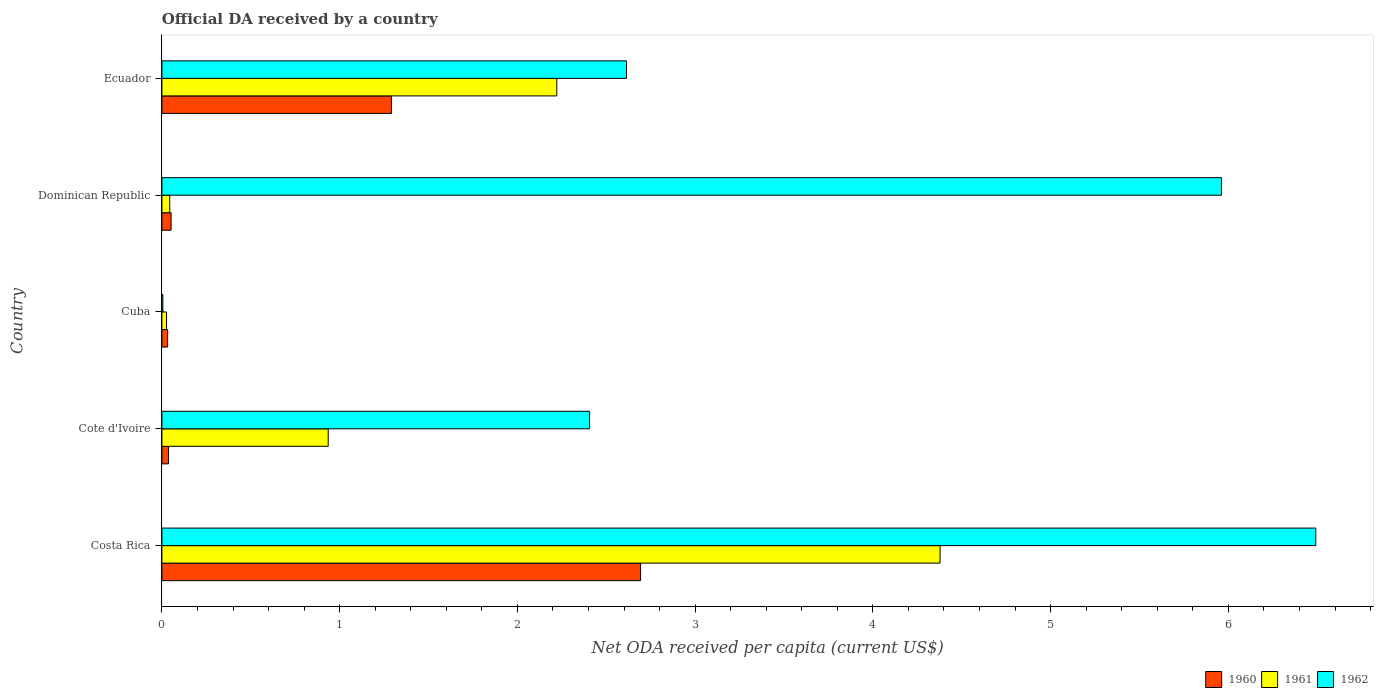How many different coloured bars are there?
Your answer should be compact. 3. Are the number of bars per tick equal to the number of legend labels?
Your response must be concise. Yes. Are the number of bars on each tick of the Y-axis equal?
Your answer should be very brief. Yes. What is the label of the 1st group of bars from the top?
Keep it short and to the point. Ecuador. What is the ODA received in in 1962 in Costa Rica?
Keep it short and to the point. 6.49. Across all countries, what is the maximum ODA received in in 1961?
Give a very brief answer. 4.38. Across all countries, what is the minimum ODA received in in 1960?
Your answer should be compact. 0.03. In which country was the ODA received in in 1961 minimum?
Your answer should be compact. Cuba. What is the total ODA received in in 1961 in the graph?
Keep it short and to the point. 7.61. What is the difference between the ODA received in in 1960 in Costa Rica and that in Cuba?
Your answer should be very brief. 2.66. What is the difference between the ODA received in in 1962 in Cuba and the ODA received in in 1961 in Ecuador?
Provide a succinct answer. -2.22. What is the average ODA received in in 1961 per country?
Offer a very short reply. 1.52. What is the difference between the ODA received in in 1961 and ODA received in in 1962 in Costa Rica?
Give a very brief answer. -2.11. What is the ratio of the ODA received in in 1961 in Cote d'Ivoire to that in Ecuador?
Your answer should be very brief. 0.42. Is the ODA received in in 1961 in Costa Rica less than that in Dominican Republic?
Keep it short and to the point. No. What is the difference between the highest and the second highest ODA received in in 1960?
Provide a succinct answer. 1.4. What is the difference between the highest and the lowest ODA received in in 1961?
Provide a short and direct response. 4.35. In how many countries, is the ODA received in in 1962 greater than the average ODA received in in 1962 taken over all countries?
Keep it short and to the point. 2. Is the sum of the ODA received in in 1960 in Dominican Republic and Ecuador greater than the maximum ODA received in in 1962 across all countries?
Give a very brief answer. No. What does the 2nd bar from the bottom in Cuba represents?
Your answer should be compact. 1961. Is it the case that in every country, the sum of the ODA received in in 1960 and ODA received in in 1961 is greater than the ODA received in in 1962?
Keep it short and to the point. No. Are all the bars in the graph horizontal?
Offer a terse response. Yes. Are the values on the major ticks of X-axis written in scientific E-notation?
Keep it short and to the point. No. Does the graph contain any zero values?
Give a very brief answer. No. Where does the legend appear in the graph?
Offer a very short reply. Bottom right. How many legend labels are there?
Provide a short and direct response. 3. What is the title of the graph?
Your response must be concise. Official DA received by a country. Does "1984" appear as one of the legend labels in the graph?
Ensure brevity in your answer.  No. What is the label or title of the X-axis?
Your response must be concise. Net ODA received per capita (current US$). What is the Net ODA received per capita (current US$) in 1960 in Costa Rica?
Offer a terse response. 2.69. What is the Net ODA received per capita (current US$) in 1961 in Costa Rica?
Make the answer very short. 4.38. What is the Net ODA received per capita (current US$) in 1962 in Costa Rica?
Provide a short and direct response. 6.49. What is the Net ODA received per capita (current US$) in 1960 in Cote d'Ivoire?
Give a very brief answer. 0.04. What is the Net ODA received per capita (current US$) of 1961 in Cote d'Ivoire?
Give a very brief answer. 0.94. What is the Net ODA received per capita (current US$) of 1962 in Cote d'Ivoire?
Your answer should be very brief. 2.41. What is the Net ODA received per capita (current US$) of 1960 in Cuba?
Give a very brief answer. 0.03. What is the Net ODA received per capita (current US$) in 1961 in Cuba?
Offer a terse response. 0.03. What is the Net ODA received per capita (current US$) of 1962 in Cuba?
Provide a short and direct response. 0.01. What is the Net ODA received per capita (current US$) in 1960 in Dominican Republic?
Offer a very short reply. 0.05. What is the Net ODA received per capita (current US$) in 1961 in Dominican Republic?
Ensure brevity in your answer.  0.04. What is the Net ODA received per capita (current US$) in 1962 in Dominican Republic?
Your answer should be very brief. 5.96. What is the Net ODA received per capita (current US$) in 1960 in Ecuador?
Offer a very short reply. 1.29. What is the Net ODA received per capita (current US$) of 1961 in Ecuador?
Your answer should be very brief. 2.22. What is the Net ODA received per capita (current US$) in 1962 in Ecuador?
Offer a very short reply. 2.61. Across all countries, what is the maximum Net ODA received per capita (current US$) in 1960?
Make the answer very short. 2.69. Across all countries, what is the maximum Net ODA received per capita (current US$) in 1961?
Provide a short and direct response. 4.38. Across all countries, what is the maximum Net ODA received per capita (current US$) in 1962?
Keep it short and to the point. 6.49. Across all countries, what is the minimum Net ODA received per capita (current US$) of 1960?
Provide a succinct answer. 0.03. Across all countries, what is the minimum Net ODA received per capita (current US$) in 1961?
Your answer should be very brief. 0.03. Across all countries, what is the minimum Net ODA received per capita (current US$) of 1962?
Your answer should be very brief. 0.01. What is the total Net ODA received per capita (current US$) of 1960 in the graph?
Provide a succinct answer. 4.11. What is the total Net ODA received per capita (current US$) of 1961 in the graph?
Keep it short and to the point. 7.61. What is the total Net ODA received per capita (current US$) in 1962 in the graph?
Provide a succinct answer. 17.48. What is the difference between the Net ODA received per capita (current US$) in 1960 in Costa Rica and that in Cote d'Ivoire?
Offer a very short reply. 2.66. What is the difference between the Net ODA received per capita (current US$) of 1961 in Costa Rica and that in Cote d'Ivoire?
Provide a short and direct response. 3.44. What is the difference between the Net ODA received per capita (current US$) of 1962 in Costa Rica and that in Cote d'Ivoire?
Your response must be concise. 4.09. What is the difference between the Net ODA received per capita (current US$) of 1960 in Costa Rica and that in Cuba?
Ensure brevity in your answer.  2.66. What is the difference between the Net ODA received per capita (current US$) of 1961 in Costa Rica and that in Cuba?
Offer a very short reply. 4.35. What is the difference between the Net ODA received per capita (current US$) in 1962 in Costa Rica and that in Cuba?
Your response must be concise. 6.49. What is the difference between the Net ODA received per capita (current US$) of 1960 in Costa Rica and that in Dominican Republic?
Offer a very short reply. 2.64. What is the difference between the Net ODA received per capita (current US$) of 1961 in Costa Rica and that in Dominican Republic?
Your response must be concise. 4.33. What is the difference between the Net ODA received per capita (current US$) in 1962 in Costa Rica and that in Dominican Republic?
Offer a terse response. 0.53. What is the difference between the Net ODA received per capita (current US$) in 1960 in Costa Rica and that in Ecuador?
Give a very brief answer. 1.4. What is the difference between the Net ODA received per capita (current US$) of 1961 in Costa Rica and that in Ecuador?
Offer a terse response. 2.16. What is the difference between the Net ODA received per capita (current US$) of 1962 in Costa Rica and that in Ecuador?
Keep it short and to the point. 3.88. What is the difference between the Net ODA received per capita (current US$) in 1960 in Cote d'Ivoire and that in Cuba?
Your answer should be very brief. 0.01. What is the difference between the Net ODA received per capita (current US$) in 1961 in Cote d'Ivoire and that in Cuba?
Keep it short and to the point. 0.91. What is the difference between the Net ODA received per capita (current US$) in 1962 in Cote d'Ivoire and that in Cuba?
Provide a short and direct response. 2.4. What is the difference between the Net ODA received per capita (current US$) of 1960 in Cote d'Ivoire and that in Dominican Republic?
Your answer should be very brief. -0.01. What is the difference between the Net ODA received per capita (current US$) in 1961 in Cote d'Ivoire and that in Dominican Republic?
Give a very brief answer. 0.89. What is the difference between the Net ODA received per capita (current US$) of 1962 in Cote d'Ivoire and that in Dominican Republic?
Make the answer very short. -3.55. What is the difference between the Net ODA received per capita (current US$) of 1960 in Cote d'Ivoire and that in Ecuador?
Your response must be concise. -1.25. What is the difference between the Net ODA received per capita (current US$) of 1961 in Cote d'Ivoire and that in Ecuador?
Give a very brief answer. -1.29. What is the difference between the Net ODA received per capita (current US$) in 1962 in Cote d'Ivoire and that in Ecuador?
Keep it short and to the point. -0.21. What is the difference between the Net ODA received per capita (current US$) in 1960 in Cuba and that in Dominican Republic?
Provide a succinct answer. -0.02. What is the difference between the Net ODA received per capita (current US$) of 1961 in Cuba and that in Dominican Republic?
Your answer should be very brief. -0.02. What is the difference between the Net ODA received per capita (current US$) in 1962 in Cuba and that in Dominican Republic?
Provide a succinct answer. -5.96. What is the difference between the Net ODA received per capita (current US$) in 1960 in Cuba and that in Ecuador?
Offer a terse response. -1.26. What is the difference between the Net ODA received per capita (current US$) of 1961 in Cuba and that in Ecuador?
Give a very brief answer. -2.2. What is the difference between the Net ODA received per capita (current US$) in 1962 in Cuba and that in Ecuador?
Ensure brevity in your answer.  -2.61. What is the difference between the Net ODA received per capita (current US$) of 1960 in Dominican Republic and that in Ecuador?
Make the answer very short. -1.24. What is the difference between the Net ODA received per capita (current US$) in 1961 in Dominican Republic and that in Ecuador?
Offer a terse response. -2.18. What is the difference between the Net ODA received per capita (current US$) in 1962 in Dominican Republic and that in Ecuador?
Provide a short and direct response. 3.35. What is the difference between the Net ODA received per capita (current US$) in 1960 in Costa Rica and the Net ODA received per capita (current US$) in 1961 in Cote d'Ivoire?
Provide a short and direct response. 1.76. What is the difference between the Net ODA received per capita (current US$) of 1960 in Costa Rica and the Net ODA received per capita (current US$) of 1962 in Cote d'Ivoire?
Give a very brief answer. 0.29. What is the difference between the Net ODA received per capita (current US$) of 1961 in Costa Rica and the Net ODA received per capita (current US$) of 1962 in Cote d'Ivoire?
Offer a very short reply. 1.97. What is the difference between the Net ODA received per capita (current US$) of 1960 in Costa Rica and the Net ODA received per capita (current US$) of 1961 in Cuba?
Your answer should be compact. 2.67. What is the difference between the Net ODA received per capita (current US$) of 1960 in Costa Rica and the Net ODA received per capita (current US$) of 1962 in Cuba?
Offer a terse response. 2.69. What is the difference between the Net ODA received per capita (current US$) of 1961 in Costa Rica and the Net ODA received per capita (current US$) of 1962 in Cuba?
Your answer should be compact. 4.37. What is the difference between the Net ODA received per capita (current US$) in 1960 in Costa Rica and the Net ODA received per capita (current US$) in 1961 in Dominican Republic?
Make the answer very short. 2.65. What is the difference between the Net ODA received per capita (current US$) in 1960 in Costa Rica and the Net ODA received per capita (current US$) in 1962 in Dominican Republic?
Your answer should be very brief. -3.27. What is the difference between the Net ODA received per capita (current US$) of 1961 in Costa Rica and the Net ODA received per capita (current US$) of 1962 in Dominican Republic?
Keep it short and to the point. -1.58. What is the difference between the Net ODA received per capita (current US$) in 1960 in Costa Rica and the Net ODA received per capita (current US$) in 1961 in Ecuador?
Ensure brevity in your answer.  0.47. What is the difference between the Net ODA received per capita (current US$) of 1960 in Costa Rica and the Net ODA received per capita (current US$) of 1962 in Ecuador?
Provide a short and direct response. 0.08. What is the difference between the Net ODA received per capita (current US$) of 1961 in Costa Rica and the Net ODA received per capita (current US$) of 1962 in Ecuador?
Keep it short and to the point. 1.76. What is the difference between the Net ODA received per capita (current US$) in 1960 in Cote d'Ivoire and the Net ODA received per capita (current US$) in 1961 in Cuba?
Provide a short and direct response. 0.01. What is the difference between the Net ODA received per capita (current US$) of 1960 in Cote d'Ivoire and the Net ODA received per capita (current US$) of 1962 in Cuba?
Your answer should be very brief. 0.03. What is the difference between the Net ODA received per capita (current US$) in 1961 in Cote d'Ivoire and the Net ODA received per capita (current US$) in 1962 in Cuba?
Your answer should be very brief. 0.93. What is the difference between the Net ODA received per capita (current US$) of 1960 in Cote d'Ivoire and the Net ODA received per capita (current US$) of 1961 in Dominican Republic?
Your answer should be very brief. -0.01. What is the difference between the Net ODA received per capita (current US$) in 1960 in Cote d'Ivoire and the Net ODA received per capita (current US$) in 1962 in Dominican Republic?
Make the answer very short. -5.92. What is the difference between the Net ODA received per capita (current US$) of 1961 in Cote d'Ivoire and the Net ODA received per capita (current US$) of 1962 in Dominican Republic?
Give a very brief answer. -5.03. What is the difference between the Net ODA received per capita (current US$) of 1960 in Cote d'Ivoire and the Net ODA received per capita (current US$) of 1961 in Ecuador?
Give a very brief answer. -2.18. What is the difference between the Net ODA received per capita (current US$) in 1960 in Cote d'Ivoire and the Net ODA received per capita (current US$) in 1962 in Ecuador?
Your response must be concise. -2.58. What is the difference between the Net ODA received per capita (current US$) of 1961 in Cote d'Ivoire and the Net ODA received per capita (current US$) of 1962 in Ecuador?
Provide a succinct answer. -1.68. What is the difference between the Net ODA received per capita (current US$) of 1960 in Cuba and the Net ODA received per capita (current US$) of 1961 in Dominican Republic?
Your answer should be very brief. -0.01. What is the difference between the Net ODA received per capita (current US$) in 1960 in Cuba and the Net ODA received per capita (current US$) in 1962 in Dominican Republic?
Give a very brief answer. -5.93. What is the difference between the Net ODA received per capita (current US$) in 1961 in Cuba and the Net ODA received per capita (current US$) in 1962 in Dominican Republic?
Provide a short and direct response. -5.93. What is the difference between the Net ODA received per capita (current US$) in 1960 in Cuba and the Net ODA received per capita (current US$) in 1961 in Ecuador?
Keep it short and to the point. -2.19. What is the difference between the Net ODA received per capita (current US$) in 1960 in Cuba and the Net ODA received per capita (current US$) in 1962 in Ecuador?
Make the answer very short. -2.58. What is the difference between the Net ODA received per capita (current US$) of 1961 in Cuba and the Net ODA received per capita (current US$) of 1962 in Ecuador?
Your answer should be very brief. -2.59. What is the difference between the Net ODA received per capita (current US$) in 1960 in Dominican Republic and the Net ODA received per capita (current US$) in 1961 in Ecuador?
Provide a succinct answer. -2.17. What is the difference between the Net ODA received per capita (current US$) of 1960 in Dominican Republic and the Net ODA received per capita (current US$) of 1962 in Ecuador?
Offer a terse response. -2.56. What is the difference between the Net ODA received per capita (current US$) of 1961 in Dominican Republic and the Net ODA received per capita (current US$) of 1962 in Ecuador?
Your answer should be very brief. -2.57. What is the average Net ODA received per capita (current US$) in 1960 per country?
Offer a terse response. 0.82. What is the average Net ODA received per capita (current US$) of 1961 per country?
Give a very brief answer. 1.52. What is the average Net ODA received per capita (current US$) in 1962 per country?
Make the answer very short. 3.5. What is the difference between the Net ODA received per capita (current US$) in 1960 and Net ODA received per capita (current US$) in 1961 in Costa Rica?
Keep it short and to the point. -1.68. What is the difference between the Net ODA received per capita (current US$) in 1960 and Net ODA received per capita (current US$) in 1962 in Costa Rica?
Keep it short and to the point. -3.8. What is the difference between the Net ODA received per capita (current US$) of 1961 and Net ODA received per capita (current US$) of 1962 in Costa Rica?
Offer a terse response. -2.11. What is the difference between the Net ODA received per capita (current US$) of 1960 and Net ODA received per capita (current US$) of 1961 in Cote d'Ivoire?
Offer a very short reply. -0.9. What is the difference between the Net ODA received per capita (current US$) of 1960 and Net ODA received per capita (current US$) of 1962 in Cote d'Ivoire?
Your answer should be very brief. -2.37. What is the difference between the Net ODA received per capita (current US$) of 1961 and Net ODA received per capita (current US$) of 1962 in Cote d'Ivoire?
Provide a short and direct response. -1.47. What is the difference between the Net ODA received per capita (current US$) of 1960 and Net ODA received per capita (current US$) of 1961 in Cuba?
Offer a terse response. 0.01. What is the difference between the Net ODA received per capita (current US$) in 1960 and Net ODA received per capita (current US$) in 1962 in Cuba?
Make the answer very short. 0.03. What is the difference between the Net ODA received per capita (current US$) in 1961 and Net ODA received per capita (current US$) in 1962 in Cuba?
Your answer should be compact. 0.02. What is the difference between the Net ODA received per capita (current US$) of 1960 and Net ODA received per capita (current US$) of 1961 in Dominican Republic?
Provide a succinct answer. 0.01. What is the difference between the Net ODA received per capita (current US$) of 1960 and Net ODA received per capita (current US$) of 1962 in Dominican Republic?
Your answer should be compact. -5.91. What is the difference between the Net ODA received per capita (current US$) in 1961 and Net ODA received per capita (current US$) in 1962 in Dominican Republic?
Offer a very short reply. -5.92. What is the difference between the Net ODA received per capita (current US$) of 1960 and Net ODA received per capita (current US$) of 1961 in Ecuador?
Offer a terse response. -0.93. What is the difference between the Net ODA received per capita (current US$) in 1960 and Net ODA received per capita (current US$) in 1962 in Ecuador?
Provide a short and direct response. -1.32. What is the difference between the Net ODA received per capita (current US$) of 1961 and Net ODA received per capita (current US$) of 1962 in Ecuador?
Your answer should be very brief. -0.39. What is the ratio of the Net ODA received per capita (current US$) of 1960 in Costa Rica to that in Cote d'Ivoire?
Your response must be concise. 71.98. What is the ratio of the Net ODA received per capita (current US$) of 1961 in Costa Rica to that in Cote d'Ivoire?
Your answer should be compact. 4.68. What is the ratio of the Net ODA received per capita (current US$) in 1962 in Costa Rica to that in Cote d'Ivoire?
Offer a very short reply. 2.7. What is the ratio of the Net ODA received per capita (current US$) of 1960 in Costa Rica to that in Cuba?
Offer a terse response. 83.62. What is the ratio of the Net ODA received per capita (current US$) in 1961 in Costa Rica to that in Cuba?
Keep it short and to the point. 167.97. What is the ratio of the Net ODA received per capita (current US$) in 1962 in Costa Rica to that in Cuba?
Provide a short and direct response. 1209.16. What is the ratio of the Net ODA received per capita (current US$) of 1960 in Costa Rica to that in Dominican Republic?
Make the answer very short. 52.18. What is the ratio of the Net ODA received per capita (current US$) of 1961 in Costa Rica to that in Dominican Republic?
Make the answer very short. 99.42. What is the ratio of the Net ODA received per capita (current US$) of 1962 in Costa Rica to that in Dominican Republic?
Your response must be concise. 1.09. What is the ratio of the Net ODA received per capita (current US$) in 1960 in Costa Rica to that in Ecuador?
Your answer should be compact. 2.09. What is the ratio of the Net ODA received per capita (current US$) in 1961 in Costa Rica to that in Ecuador?
Provide a succinct answer. 1.97. What is the ratio of the Net ODA received per capita (current US$) of 1962 in Costa Rica to that in Ecuador?
Give a very brief answer. 2.48. What is the ratio of the Net ODA received per capita (current US$) of 1960 in Cote d'Ivoire to that in Cuba?
Keep it short and to the point. 1.16. What is the ratio of the Net ODA received per capita (current US$) in 1961 in Cote d'Ivoire to that in Cuba?
Your answer should be very brief. 35.9. What is the ratio of the Net ODA received per capita (current US$) of 1962 in Cote d'Ivoire to that in Cuba?
Give a very brief answer. 448.16. What is the ratio of the Net ODA received per capita (current US$) in 1960 in Cote d'Ivoire to that in Dominican Republic?
Your answer should be very brief. 0.72. What is the ratio of the Net ODA received per capita (current US$) of 1961 in Cote d'Ivoire to that in Dominican Republic?
Make the answer very short. 21.25. What is the ratio of the Net ODA received per capita (current US$) of 1962 in Cote d'Ivoire to that in Dominican Republic?
Your response must be concise. 0.4. What is the ratio of the Net ODA received per capita (current US$) of 1960 in Cote d'Ivoire to that in Ecuador?
Your answer should be compact. 0.03. What is the ratio of the Net ODA received per capita (current US$) in 1961 in Cote d'Ivoire to that in Ecuador?
Offer a terse response. 0.42. What is the ratio of the Net ODA received per capita (current US$) of 1962 in Cote d'Ivoire to that in Ecuador?
Make the answer very short. 0.92. What is the ratio of the Net ODA received per capita (current US$) of 1960 in Cuba to that in Dominican Republic?
Offer a terse response. 0.62. What is the ratio of the Net ODA received per capita (current US$) of 1961 in Cuba to that in Dominican Republic?
Keep it short and to the point. 0.59. What is the ratio of the Net ODA received per capita (current US$) of 1962 in Cuba to that in Dominican Republic?
Offer a very short reply. 0. What is the ratio of the Net ODA received per capita (current US$) in 1960 in Cuba to that in Ecuador?
Your response must be concise. 0.02. What is the ratio of the Net ODA received per capita (current US$) of 1961 in Cuba to that in Ecuador?
Your response must be concise. 0.01. What is the ratio of the Net ODA received per capita (current US$) in 1962 in Cuba to that in Ecuador?
Your answer should be very brief. 0. What is the ratio of the Net ODA received per capita (current US$) in 1961 in Dominican Republic to that in Ecuador?
Offer a very short reply. 0.02. What is the ratio of the Net ODA received per capita (current US$) of 1962 in Dominican Republic to that in Ecuador?
Provide a succinct answer. 2.28. What is the difference between the highest and the second highest Net ODA received per capita (current US$) of 1960?
Offer a very short reply. 1.4. What is the difference between the highest and the second highest Net ODA received per capita (current US$) of 1961?
Your response must be concise. 2.16. What is the difference between the highest and the second highest Net ODA received per capita (current US$) in 1962?
Your answer should be compact. 0.53. What is the difference between the highest and the lowest Net ODA received per capita (current US$) in 1960?
Offer a very short reply. 2.66. What is the difference between the highest and the lowest Net ODA received per capita (current US$) in 1961?
Make the answer very short. 4.35. What is the difference between the highest and the lowest Net ODA received per capita (current US$) of 1962?
Your response must be concise. 6.49. 